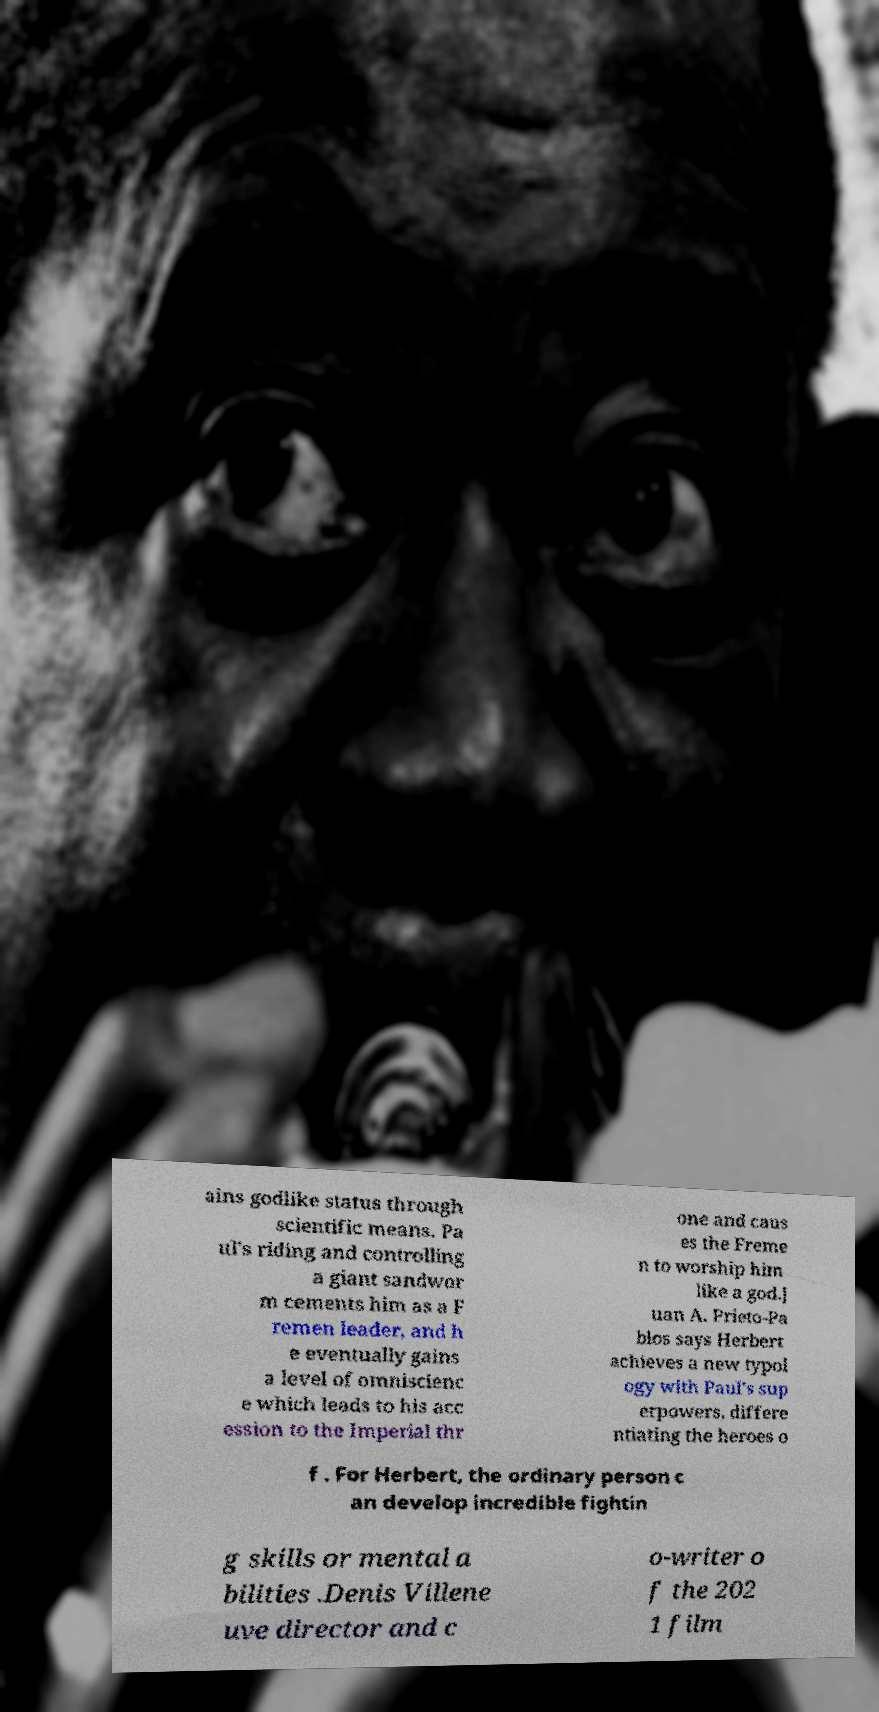Please identify and transcribe the text found in this image. ains godlike status through scientific means. Pa ul's riding and controlling a giant sandwor m cements him as a F remen leader, and h e eventually gains a level of omniscienc e which leads to his acc ession to the Imperial thr one and caus es the Freme n to worship him like a god.J uan A. Prieto-Pa blos says Herbert achieves a new typol ogy with Paul's sup erpowers, differe ntiating the heroes o f . For Herbert, the ordinary person c an develop incredible fightin g skills or mental a bilities .Denis Villene uve director and c o-writer o f the 202 1 film 